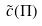Convert formula to latex. <formula><loc_0><loc_0><loc_500><loc_500>\tilde { c } ( \Pi )</formula> 